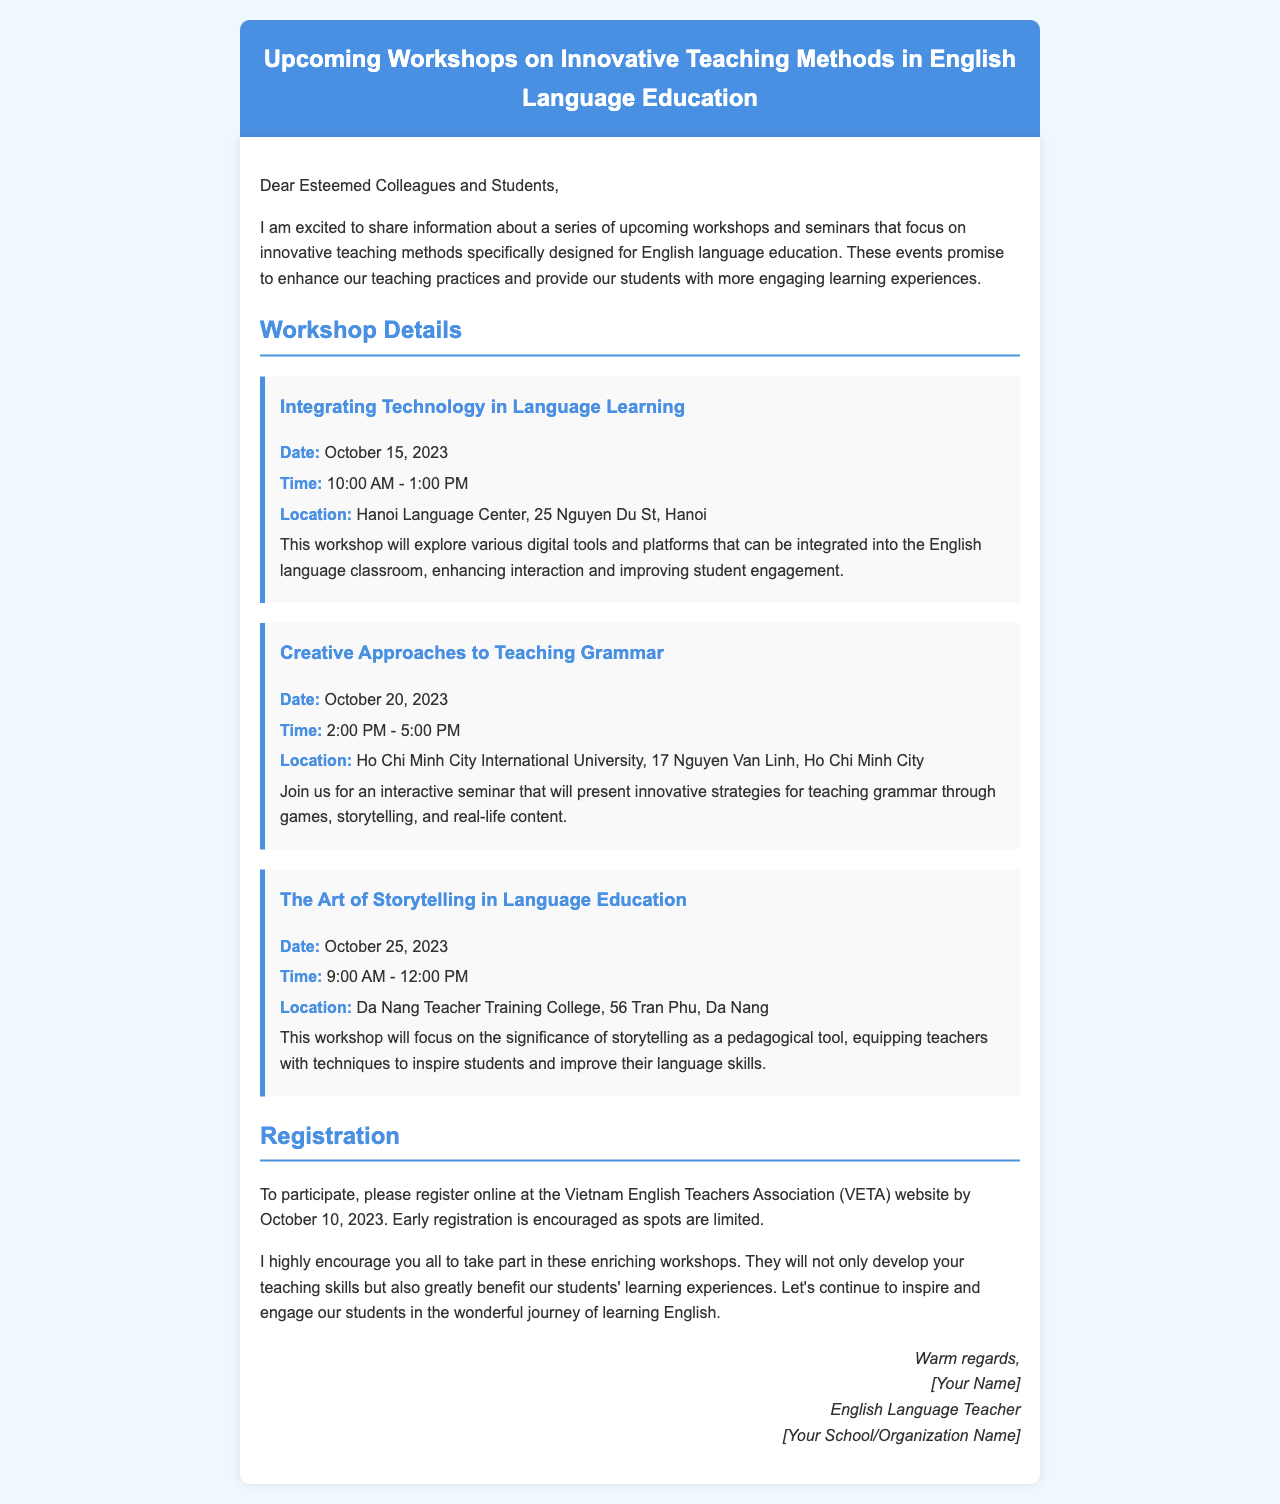What is the date of the workshop on integrating technology? The date for the workshop on integrating technology is specifically mentioned above.
Answer: October 15, 2023 What is the location of the seminar about teaching grammar? The seminar is to be held at a specific university in Ho Chi Minh City, as stated in the document.
Answer: Ho Chi Minh City International University What is the time for the storytelling workshop? The time for the workshop is explicitly noted in the document.
Answer: 9:00 AM - 12:00 PM How many workshops are mentioned in the document? The number of workshops can be counted based on the content provided.
Answer: Three When is the registration deadline? The document clearly states the deadline for registration.
Answer: October 10, 2023 Why are early registrations encouraged? The document suggests limited spots as a reason for encouraging early registration.
Answer: Spots are limited What is the main focus of the workshop on integrating technology? The primary aim of this workshop is outlined in a detailed description.
Answer: Digital tools and platforms Who is the intended audience for these workshops? The document specifies the audience that is encouraged to participate.
Answer: Colleagues and students 